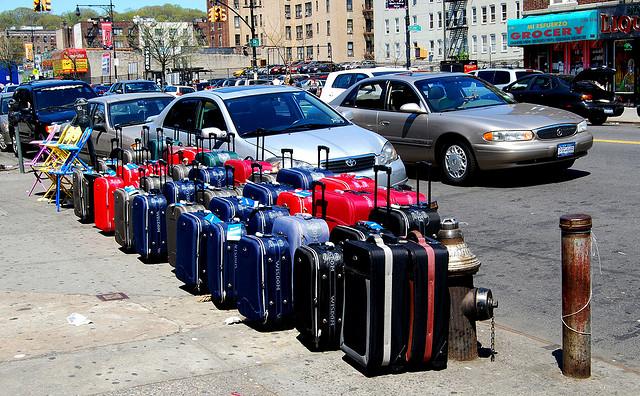What kind of store is advertised on blue sign?
Give a very brief answer. Grocery. What color is the automobile in the picture?
Concise answer only. Silver. What is in the foreground?
Concise answer only. Suitcases. Where is this?
Concise answer only. City. Are clouds visible?
Keep it brief. No. 